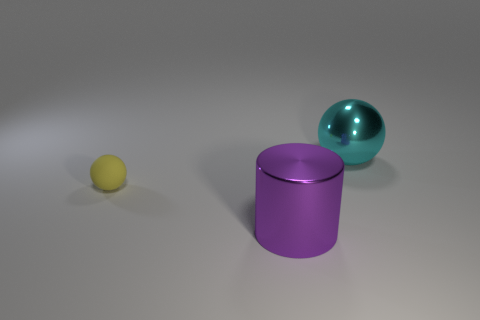Add 2 tiny red blocks. How many objects exist? 5 Subtract all cylinders. How many objects are left? 2 Add 3 cyan spheres. How many cyan spheres are left? 4 Add 1 tiny yellow rubber spheres. How many tiny yellow rubber spheres exist? 2 Subtract 0 green blocks. How many objects are left? 3 Subtract all small purple metallic cylinders. Subtract all big things. How many objects are left? 1 